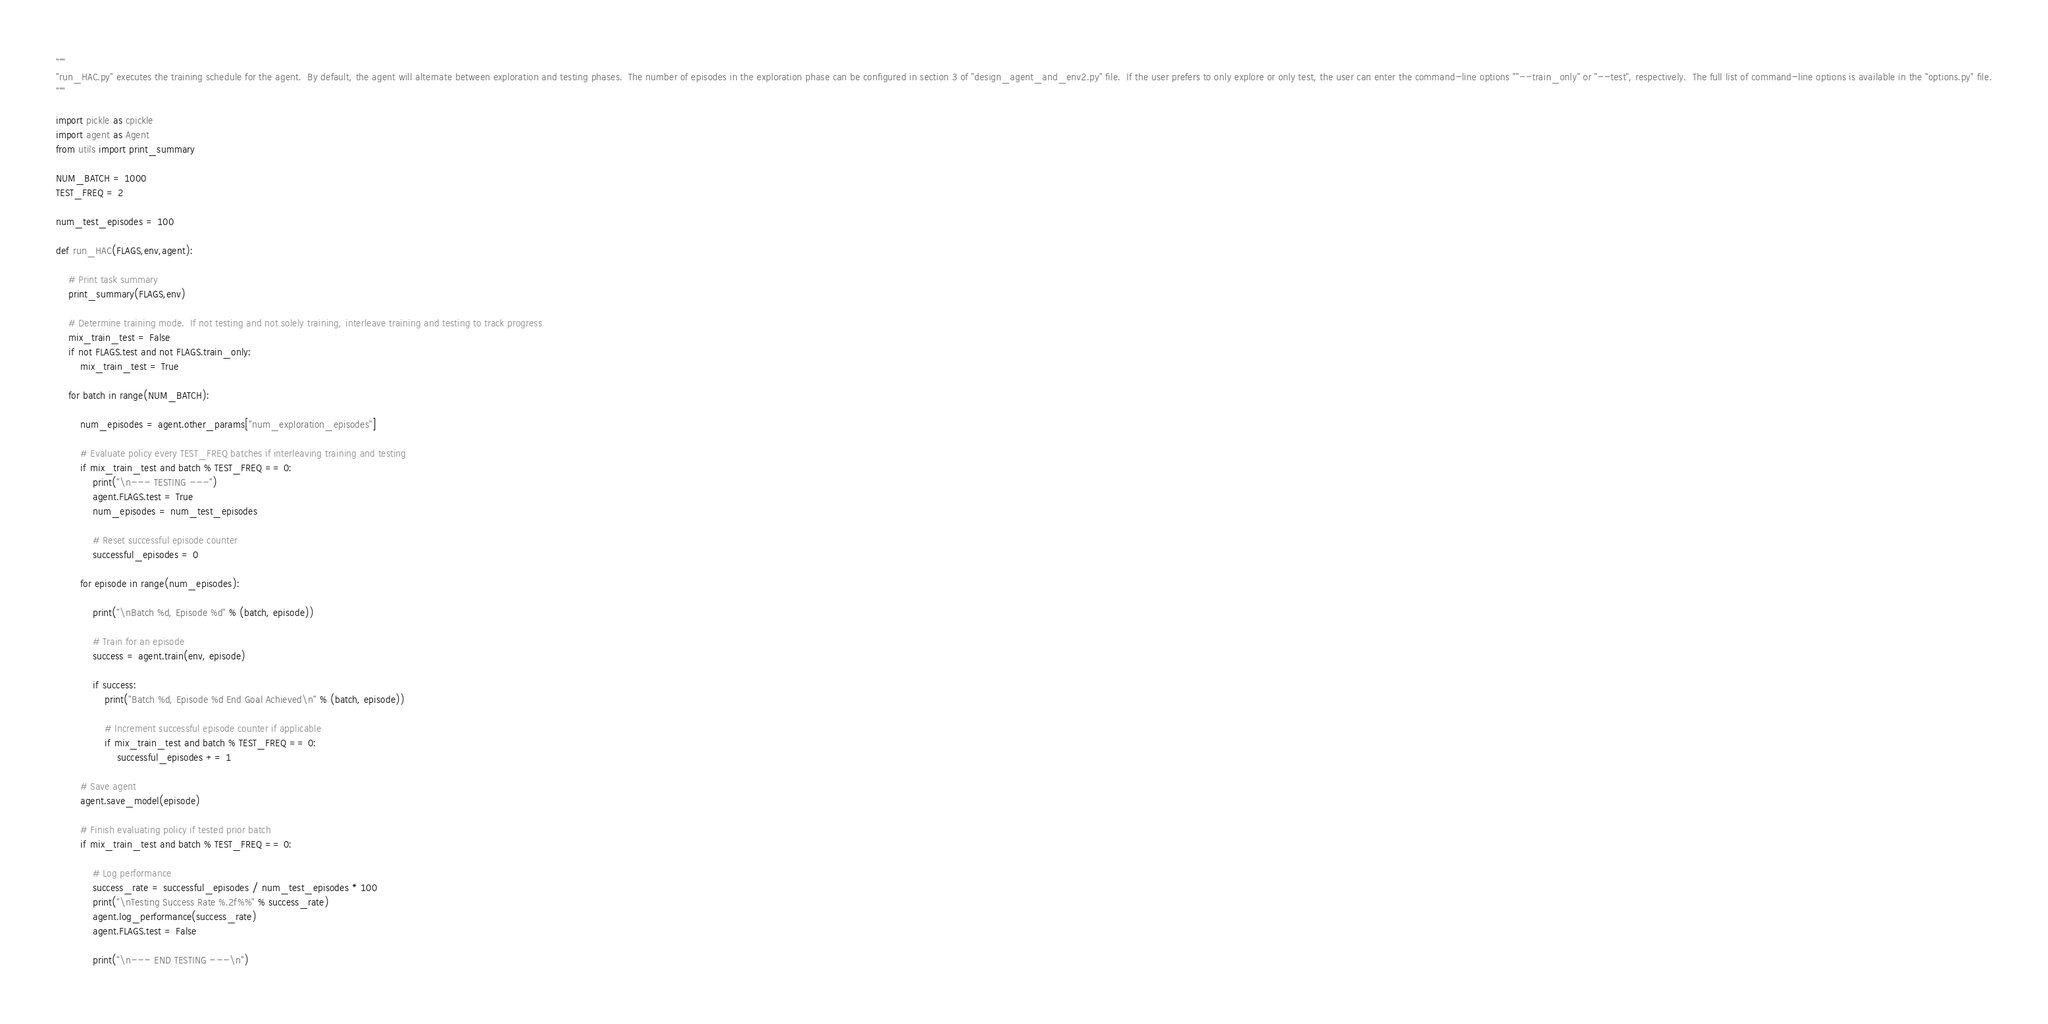<code> <loc_0><loc_0><loc_500><loc_500><_Python_>"""
"run_HAC.py" executes the training schedule for the agent.  By default, the agent will alternate between exploration and testing phases.  The number of episodes in the exploration phase can be configured in section 3 of "design_agent_and_env2.py" file.  If the user prefers to only explore or only test, the user can enter the command-line options ""--train_only" or "--test", respectively.  The full list of command-line options is available in the "options.py" file.
"""

import pickle as cpickle
import agent as Agent
from utils import print_summary

NUM_BATCH = 1000
TEST_FREQ = 2

num_test_episodes = 100

def run_HAC(FLAGS,env,agent):

    # Print task summary
    print_summary(FLAGS,env)
    
    # Determine training mode.  If not testing and not solely training, interleave training and testing to track progress
    mix_train_test = False
    if not FLAGS.test and not FLAGS.train_only:
        mix_train_test = True
     
    for batch in range(NUM_BATCH):

        num_episodes = agent.other_params["num_exploration_episodes"]
        
        # Evaluate policy every TEST_FREQ batches if interleaving training and testing
        if mix_train_test and batch % TEST_FREQ == 0:
            print("\n--- TESTING ---")
            agent.FLAGS.test = True
            num_episodes = num_test_episodes            

            # Reset successful episode counter
            successful_episodes = 0

        for episode in range(num_episodes):
            
            print("\nBatch %d, Episode %d" % (batch, episode))
            
            # Train for an episode
            success = agent.train(env, episode)

            if success:
                print("Batch %d, Episode %d End Goal Achieved\n" % (batch, episode))
                
                # Increment successful episode counter if applicable
                if mix_train_test and batch % TEST_FREQ == 0:
                    successful_episodes += 1            

        # Save agent
        agent.save_model(episode)
           
        # Finish evaluating policy if tested prior batch
        if mix_train_test and batch % TEST_FREQ == 0:

            # Log performance
            success_rate = successful_episodes / num_test_episodes * 100
            print("\nTesting Success Rate %.2f%%" % success_rate)
            agent.log_performance(success_rate)
            agent.FLAGS.test = False

            print("\n--- END TESTING ---\n")
</code> 